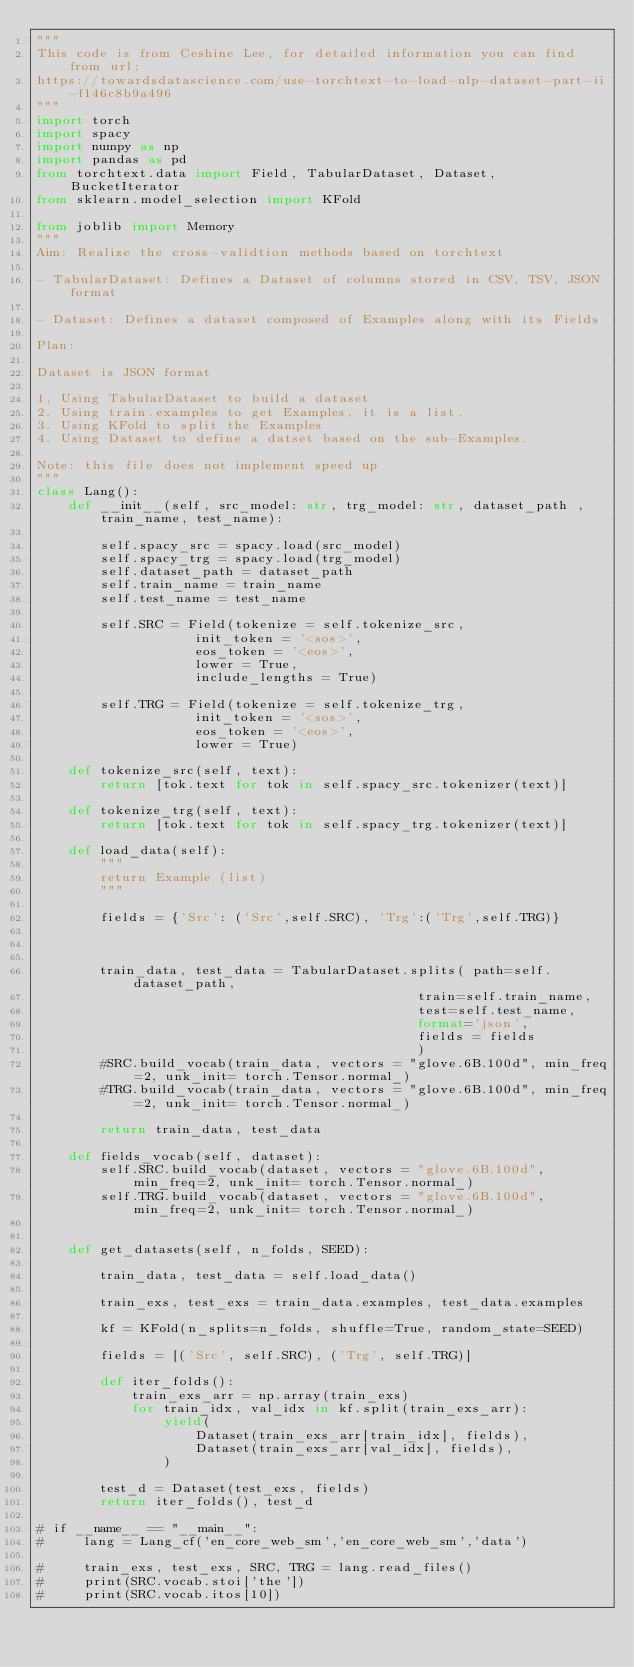<code> <loc_0><loc_0><loc_500><loc_500><_Python_>"""
This code is from Ceshine Lee, for detailed information you can find from url:
https://towardsdatascience.com/use-torchtext-to-load-nlp-dataset-part-ii-f146c8b9a496
"""
import torch
import spacy
import numpy as np
import pandas as pd
from torchtext.data import Field, TabularDataset, Dataset, BucketIterator
from sklearn.model_selection import KFold

from joblib import Memory
"""
Aim: Realize the cross-validtion methods based on torchtext

- TabularDataset: Defines a Dataset of columns stored in CSV, TSV, JSON format

- Dataset: Defines a dataset composed of Examples along with its Fields

Plan:

Dataset is JSON format

1, Using TabularDataset to build a dataset
2. Using train.examples to get Examples, it is a list.
3. Using KFold to split the Examples
4. Using Dataset to define a datset based on the sub-Examples.

Note: this file does not implement speed up
"""
class Lang():
    def __init__(self, src_model: str, trg_model: str, dataset_path , train_name, test_name):
        
        self.spacy_src = spacy.load(src_model)
        self.spacy_trg = spacy.load(trg_model)
        self.dataset_path = dataset_path
        self.train_name = train_name
        self.test_name = test_name

        self.SRC = Field(tokenize = self.tokenize_src, 
                    init_token = '<sos>', 
                    eos_token = '<eos>', 
                    lower = True, 
                    include_lengths = True)

        self.TRG = Field(tokenize = self.tokenize_trg, 
                    init_token = '<sos>', 
                    eos_token = '<eos>', 
                    lower = True)
    
    def tokenize_src(self, text):
        return [tok.text for tok in self.spacy_src.tokenizer(text)]

    def tokenize_trg(self, text):
        return [tok.text for tok in self.spacy_trg.tokenizer(text)]

    def load_data(self):
        """
        return Example (list)
        """

        fields = {'Src': ('Src',self.SRC), 'Trg':('Trg',self.TRG)}



        train_data, test_data = TabularDataset.splits( path=self.dataset_path,
                                                train=self.train_name,
                                                test=self.test_name,
                                                format='json',
                                                fields = fields
                                                )
        #SRC.build_vocab(train_data, vectors = "glove.6B.100d", min_freq=2, unk_init= torch.Tensor.normal_)
        #TRG.build_vocab(train_data, vectors = "glove.6B.100d", min_freq=2, unk_init= torch.Tensor.normal_)

        return train_data, test_data

    def fields_vocab(self, dataset):
        self.SRC.build_vocab(dataset, vectors = "glove.6B.100d", min_freq=2, unk_init= torch.Tensor.normal_)
        self.TRG.build_vocab(dataset, vectors = "glove.6B.100d", min_freq=2, unk_init= torch.Tensor.normal_)


    def get_datasets(self, n_folds, SEED):
        
        train_data, test_data = self.load_data()

        train_exs, test_exs = train_data.examples, test_data.examples

        kf = KFold(n_splits=n_folds, shuffle=True, random_state=SEED)

        fields = [('Src', self.SRC), ('Trg', self.TRG)]

        def iter_folds():
            train_exs_arr = np.array(train_exs)
            for train_idx, val_idx in kf.split(train_exs_arr):
                yield(
                    Dataset(train_exs_arr[train_idx], fields),
                    Dataset(train_exs_arr[val_idx], fields),
                )
        
        test_d = Dataset(test_exs, fields)
        return iter_folds(), test_d

# if __name__ == "__main__":
#     lang = Lang_cf('en_core_web_sm','en_core_web_sm','data')
   
#     train_exs, test_exs, SRC, TRG = lang.read_files()
#     print(SRC.vocab.stoi['the'])
#     print(SRC.vocab.itos[10])</code> 